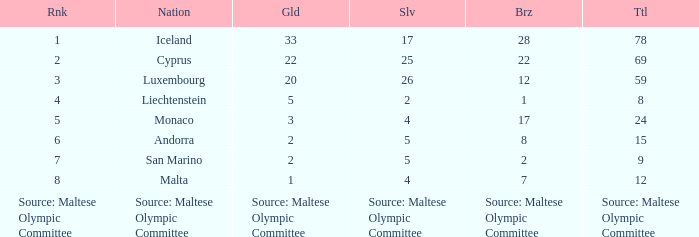How many bronze medals does the nation ranked number 1 have? 28.0. 